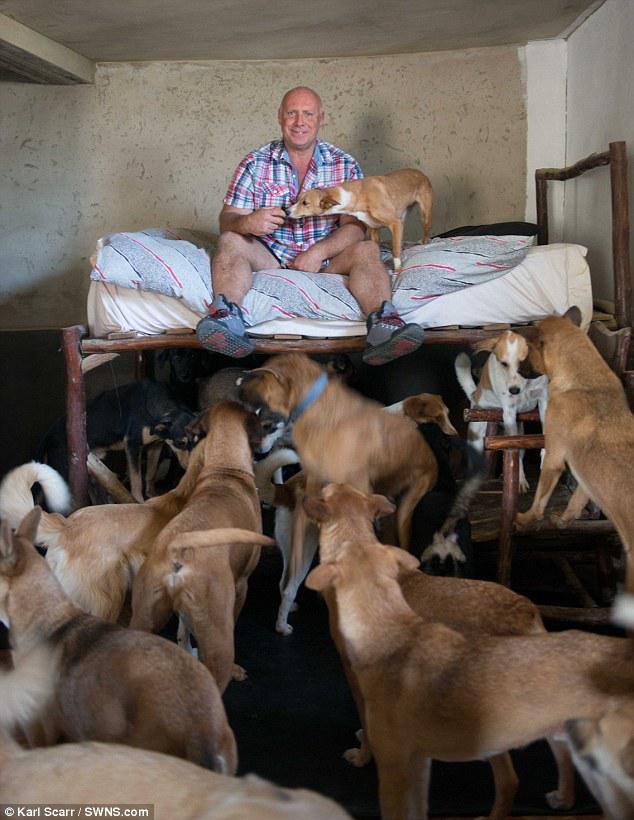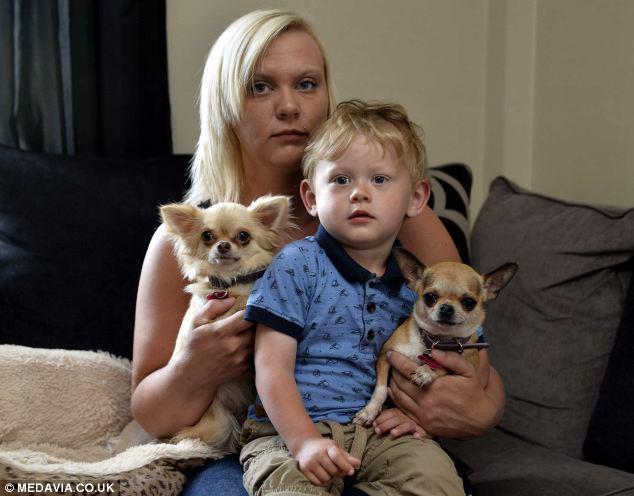The first image is the image on the left, the second image is the image on the right. Examine the images to the left and right. Is the description "An image shows two small chihuahuas, one on each side of a male person facing the camera." accurate? Answer yes or no. Yes. The first image is the image on the left, the second image is the image on the right. For the images shown, is this caption "The right image contains exactly two dogs." true? Answer yes or no. Yes. 